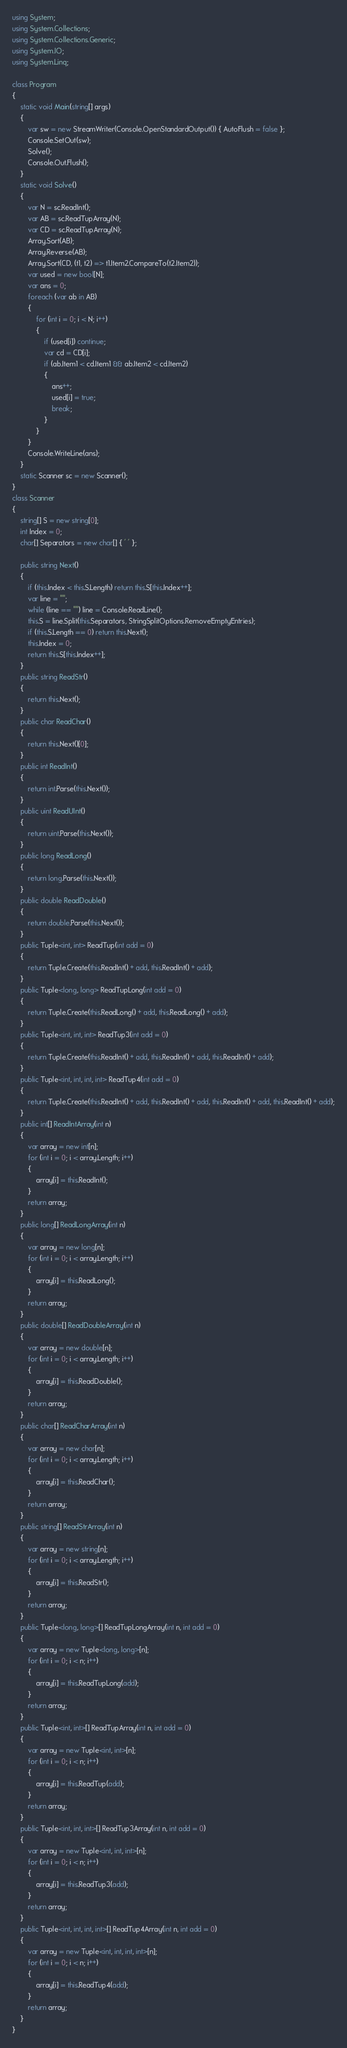<code> <loc_0><loc_0><loc_500><loc_500><_C#_>using System;
using System.Collections;
using System.Collections.Generic;
using System.IO;
using System.Linq;

class Program
{
    static void Main(string[] args)
    {
        var sw = new StreamWriter(Console.OpenStandardOutput()) { AutoFlush = false };
        Console.SetOut(sw);
        Solve();
        Console.Out.Flush();
    }
    static void Solve()
    {
        var N = sc.ReadInt();
        var AB = sc.ReadTupArray(N);
        var CD = sc.ReadTupArray(N);
        Array.Sort(AB);
        Array.Reverse(AB);
        Array.Sort(CD, (t1, t2) => t1.Item2.CompareTo(t2.Item2));
        var used = new bool[N];
        var ans = 0;
        foreach (var ab in AB)
        {
            for (int i = 0; i < N; i++)
            {
                if (used[i]) continue;
                var cd = CD[i];
                if (ab.Item1 < cd.Item1 && ab.Item2 < cd.Item2)
                {
                    ans++;
                    used[i] = true;
                    break;
                }
            }
        }
        Console.WriteLine(ans);
    }
    static Scanner sc = new Scanner();
}
class Scanner
{
    string[] S = new string[0];
    int Index = 0;
    char[] Separators = new char[] { ' ' };

    public string Next()
    {
        if (this.Index < this.S.Length) return this.S[this.Index++];
        var line = "";
        while (line == "") line = Console.ReadLine();
        this.S = line.Split(this.Separators, StringSplitOptions.RemoveEmptyEntries);
        if (this.S.Length == 0) return this.Next();
        this.Index = 0;
        return this.S[this.Index++];
    }
    public string ReadStr()
    {
        return this.Next();
    }
    public char ReadChar()
    {
        return this.Next()[0];
    }
    public int ReadInt()
    {
        return int.Parse(this.Next());
    }
    public uint ReadUInt()
    {
        return uint.Parse(this.Next());
    }
    public long ReadLong()
    {
        return long.Parse(this.Next());
    }
    public double ReadDouble()
    {
        return double.Parse(this.Next());
    }
    public Tuple<int, int> ReadTup(int add = 0)
    {
        return Tuple.Create(this.ReadInt() + add, this.ReadInt() + add);
    }
    public Tuple<long, long> ReadTupLong(int add = 0)
    {
        return Tuple.Create(this.ReadLong() + add, this.ReadLong() + add);
    }
    public Tuple<int, int, int> ReadTup3(int add = 0)
    {
        return Tuple.Create(this.ReadInt() + add, this.ReadInt() + add, this.ReadInt() + add);
    }
    public Tuple<int, int, int, int> ReadTup4(int add = 0)
    {
        return Tuple.Create(this.ReadInt() + add, this.ReadInt() + add, this.ReadInt() + add, this.ReadInt() + add);
    }
    public int[] ReadIntArray(int n)
    {
        var array = new int[n];
        for (int i = 0; i < array.Length; i++)
        {
            array[i] = this.ReadInt();
        }
        return array;
    }
    public long[] ReadLongArray(int n)
    {
        var array = new long[n];
        for (int i = 0; i < array.Length; i++)
        {
            array[i] = this.ReadLong();
        }
        return array;
    }
    public double[] ReadDoubleArray(int n)
    {
        var array = new double[n];
        for (int i = 0; i < array.Length; i++)
        {
            array[i] = this.ReadDouble();
        }
        return array;
    }
    public char[] ReadCharArray(int n)
    {
        var array = new char[n];
        for (int i = 0; i < array.Length; i++)
        {
            array[i] = this.ReadChar();
        }
        return array;
    }
    public string[] ReadStrArray(int n)
    {
        var array = new string[n];
        for (int i = 0; i < array.Length; i++)
        {
            array[i] = this.ReadStr();
        }
        return array;
    }
    public Tuple<long, long>[] ReadTupLongArray(int n, int add = 0)
    {
        var array = new Tuple<long, long>[n];
        for (int i = 0; i < n; i++)
        {
            array[i] = this.ReadTupLong(add);
        }
        return array;
    }
    public Tuple<int, int>[] ReadTupArray(int n, int add = 0)
    {
        var array = new Tuple<int, int>[n];
        for (int i = 0; i < n; i++)
        {
            array[i] = this.ReadTup(add);
        }
        return array;
    }
    public Tuple<int, int, int>[] ReadTup3Array(int n, int add = 0)
    {
        var array = new Tuple<int, int, int>[n];
        for (int i = 0; i < n; i++)
        {
            array[i] = this.ReadTup3(add);
        }
        return array;
    }
    public Tuple<int, int, int, int>[] ReadTup4Array(int n, int add = 0)
    {
        var array = new Tuple<int, int, int, int>[n];
        for (int i = 0; i < n; i++)
        {
            array[i] = this.ReadTup4(add);
        }
        return array;
    }
}
</code> 